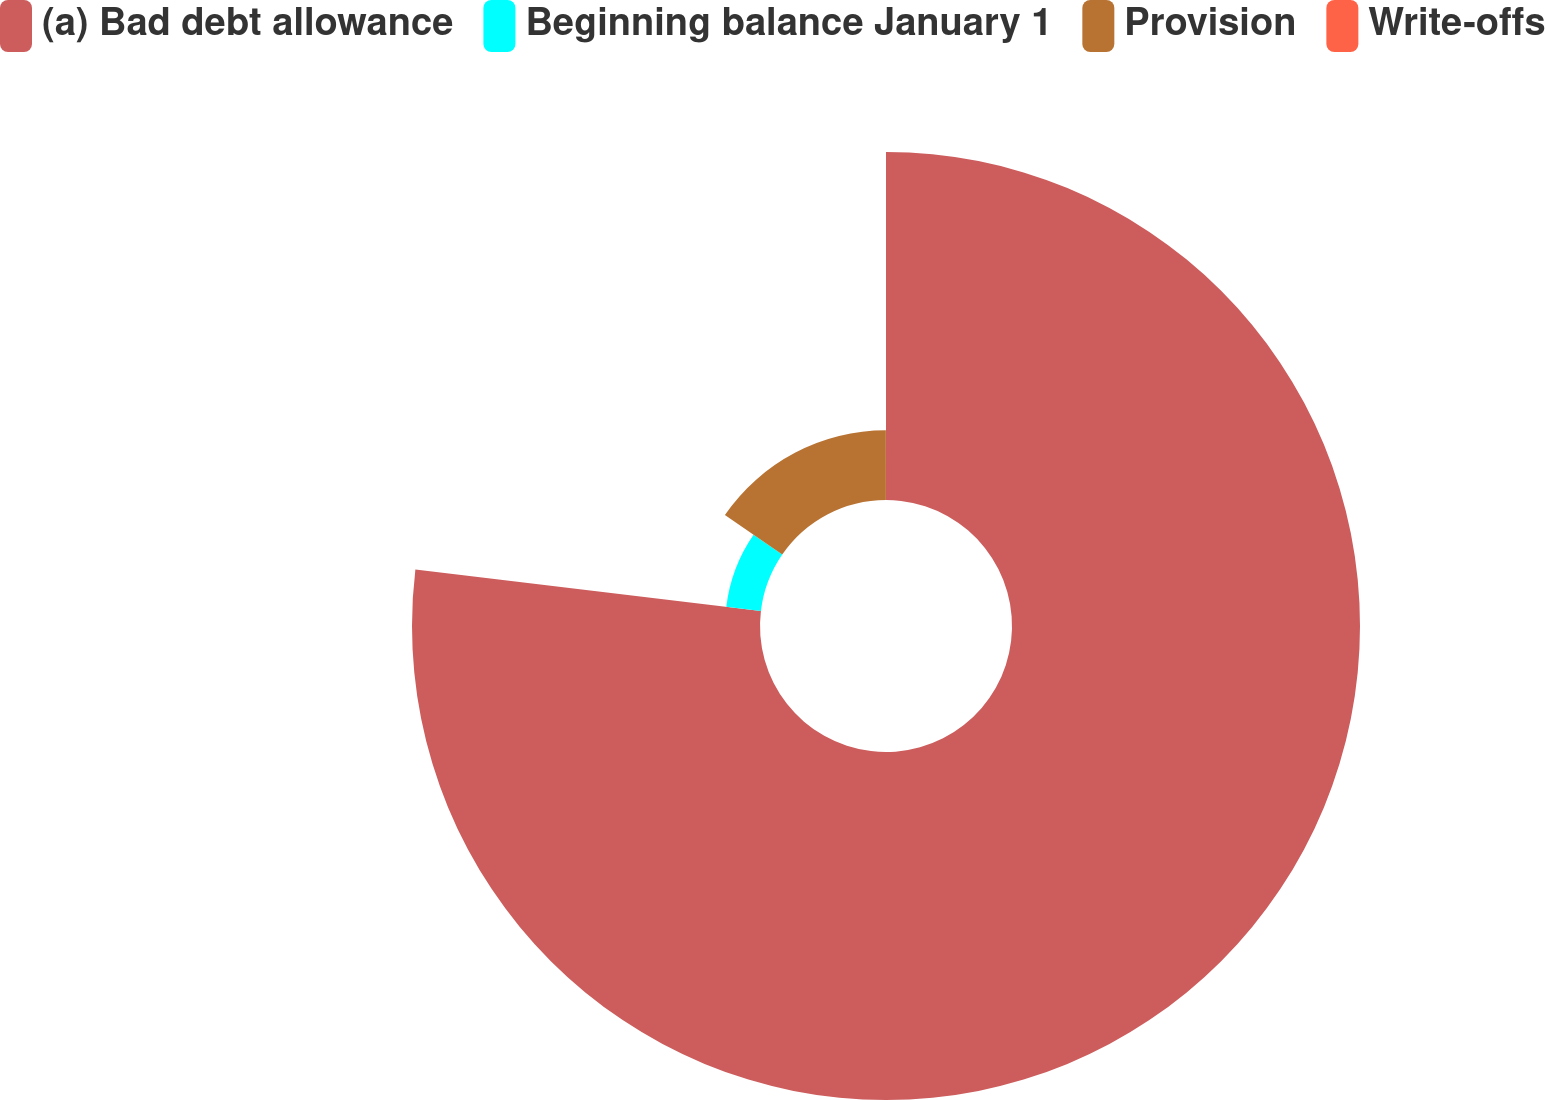<chart> <loc_0><loc_0><loc_500><loc_500><pie_chart><fcel>(a) Bad debt allowance<fcel>Beginning balance January 1<fcel>Provision<fcel>Write-offs<nl><fcel>76.91%<fcel>7.7%<fcel>15.39%<fcel>0.01%<nl></chart> 